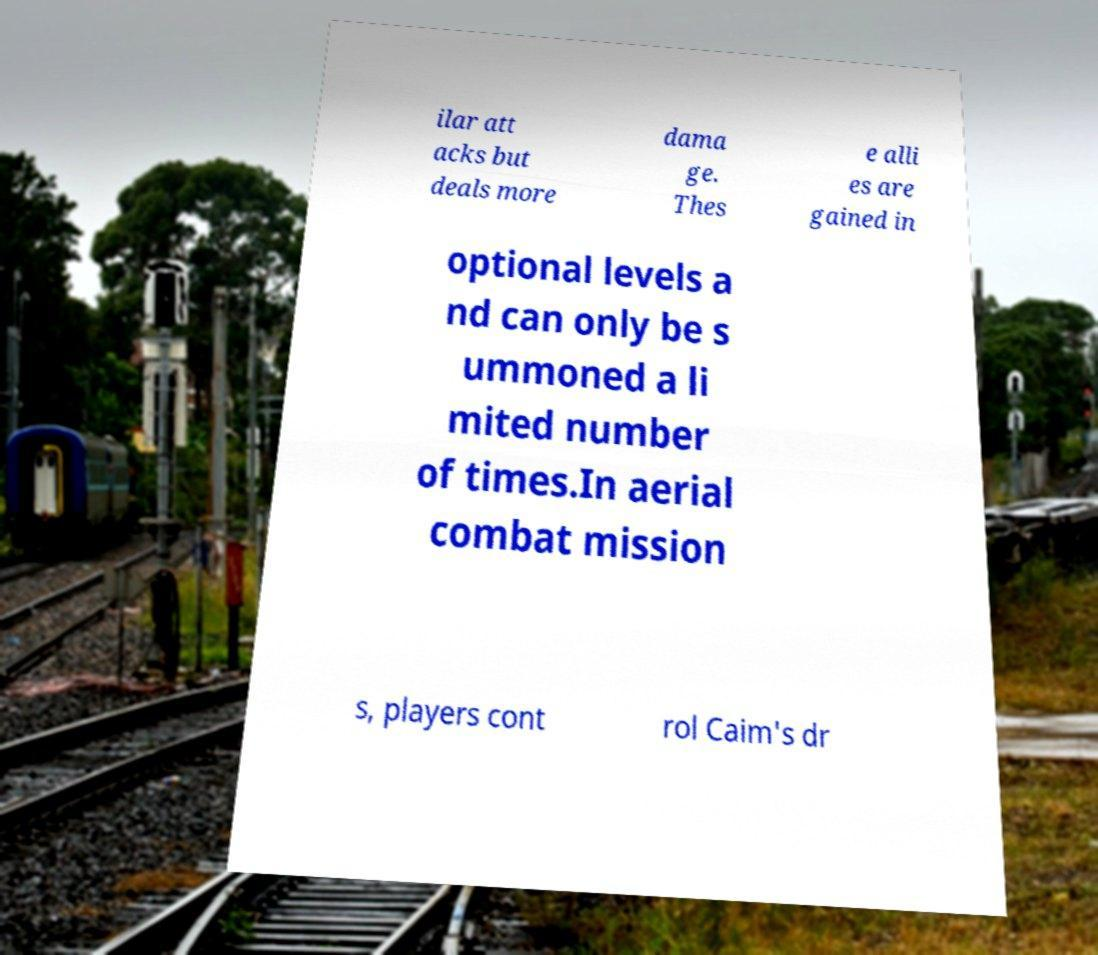For documentation purposes, I need the text within this image transcribed. Could you provide that? ilar att acks but deals more dama ge. Thes e alli es are gained in optional levels a nd can only be s ummoned a li mited number of times.In aerial combat mission s, players cont rol Caim's dr 